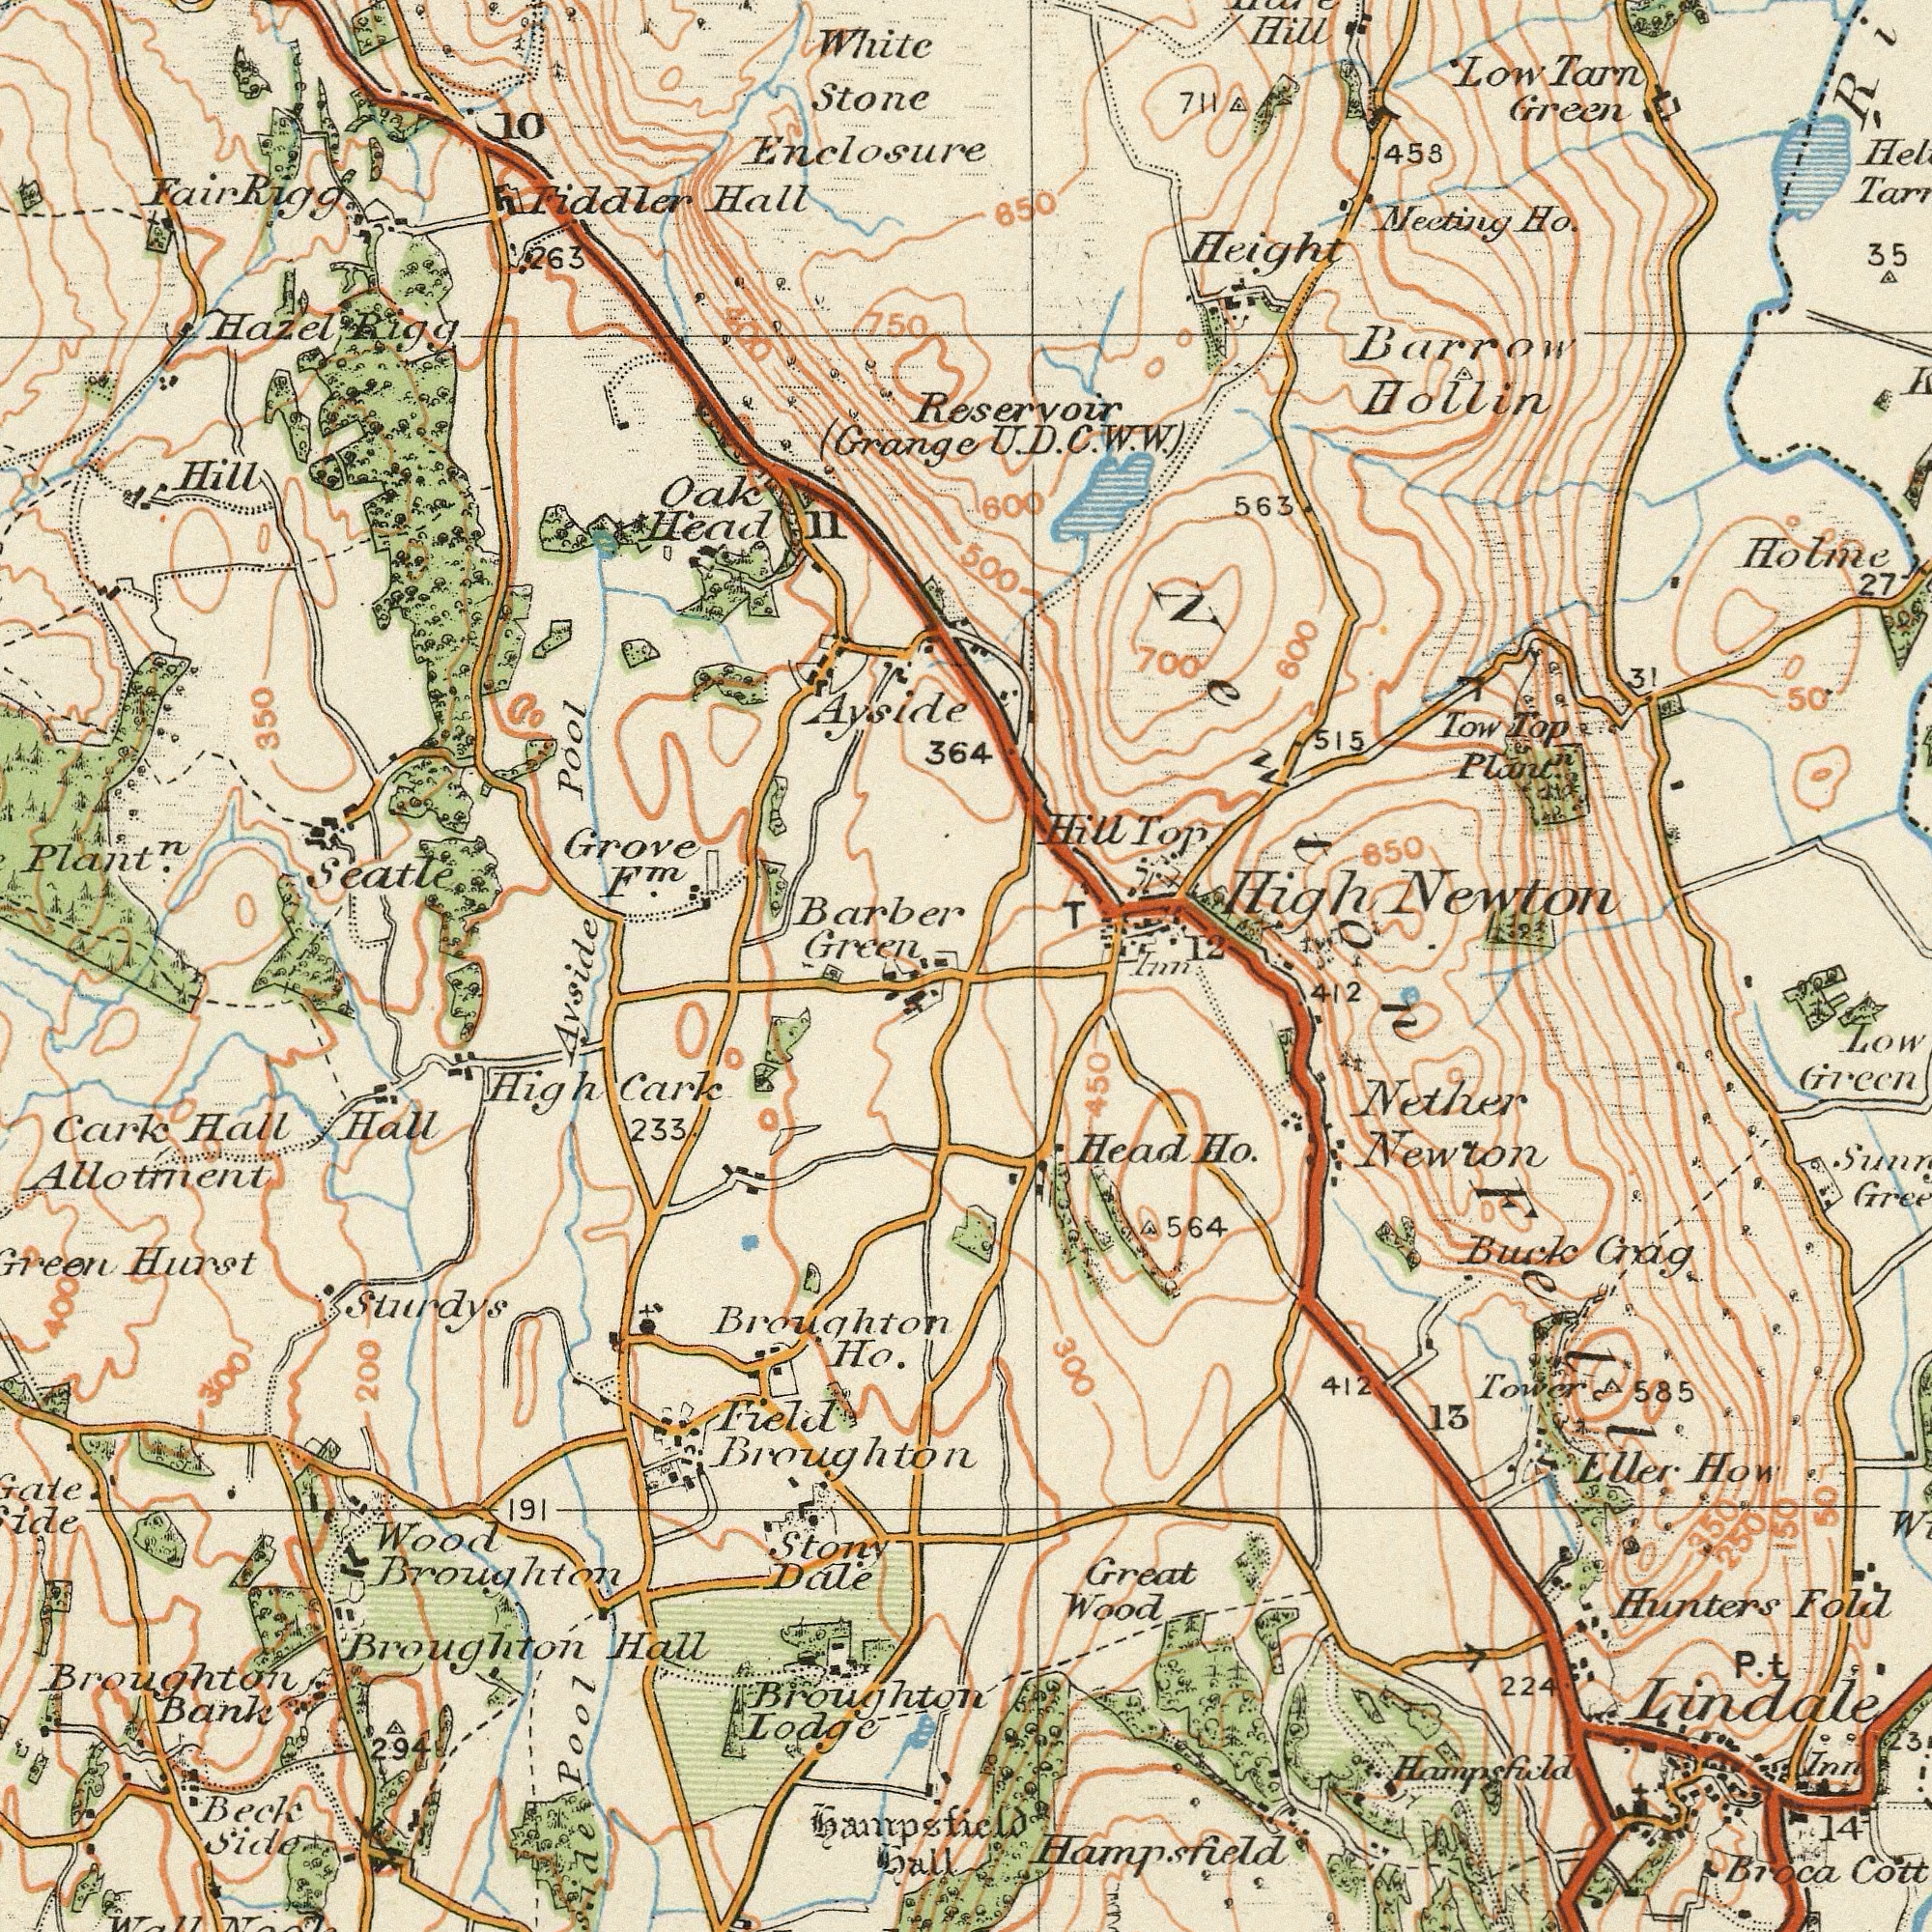What text appears in the bottom-right area of the image? Newton Green Buck Lindale Eller Low Great Head Wood Ho. Fold How Inn 13 Tower 585 224 Nether 412 412 Hampsfield Crag 564 P. 14 Hampsfield Hunters 300 450 Broca Fell Inn 350 250 150 50 t What text appears in the bottom-left area of the image? Cark Field Hurst Bank Hall Ho. 233 Broughton Hall Stony Beck Hall Hall Dale Pool Green Allotment Sturdys Hampsfield Broughton 200 191 Avside Wood Lodge Side Broughton Cark High 294 Broughton Broughton Broughton 300 400 What text can you see in the top-left section? White Stone Grove Green Seatle Hall (Grange Plant<sup>n</sup>. Fiddler Barber Fair Ayside Hazel Head 10 Hill Oak 263 Enclosure Rigg Pool 11 F<sup>m</sup>. 364 Rigg 750 400 350 What text is visible in the upper-right corner? Hollin Barrow High Green Reservoir Plant<sup>n</sup>. 458 650 Top 850 515 35 Tow Low 600 700 T Tarn Hill Holme Newton 50 27 12 563 Ho. Meeting 31 Height Top Hill 600 U. 500 711 Newton D. C. W. W.) 